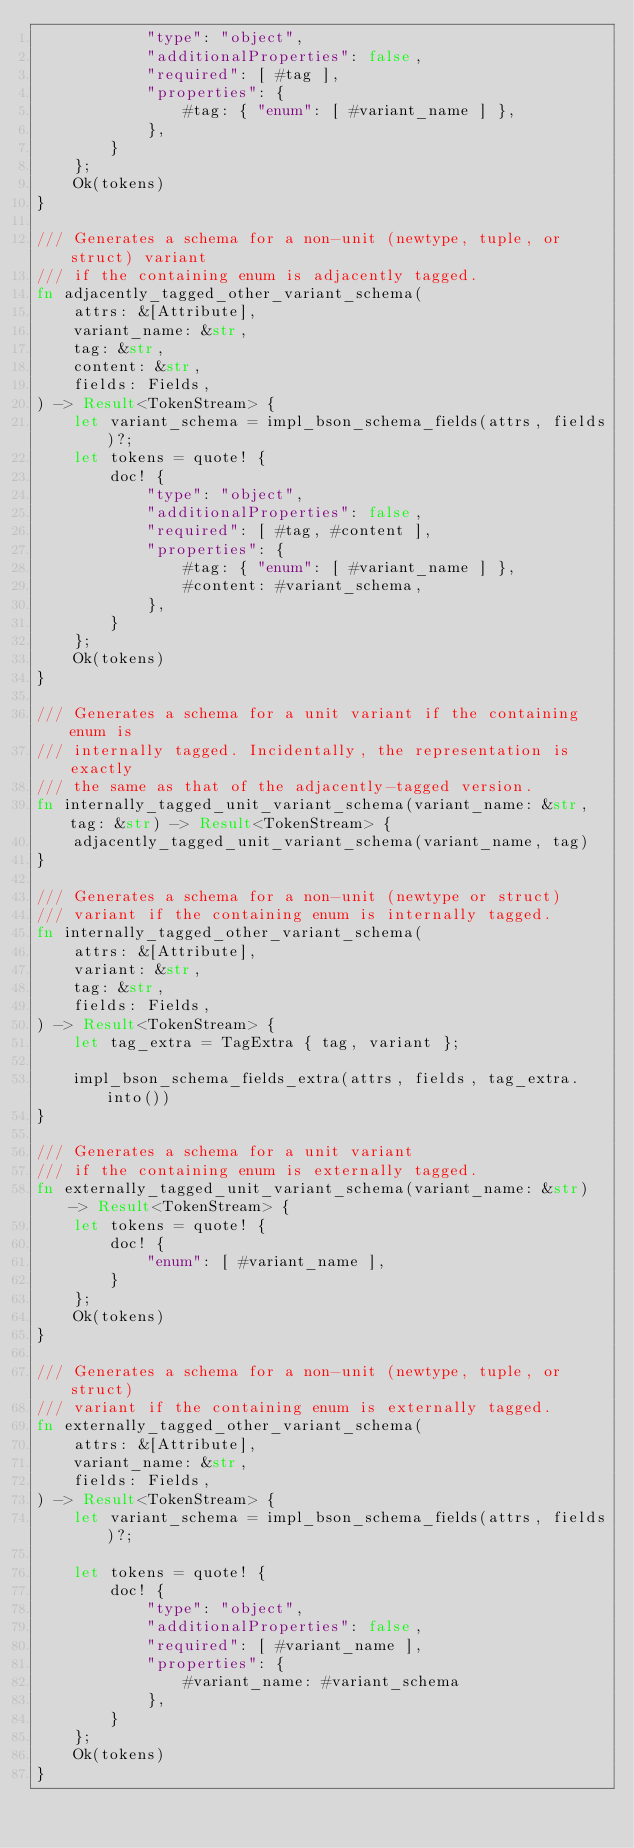<code> <loc_0><loc_0><loc_500><loc_500><_Rust_>            "type": "object",
            "additionalProperties": false,
            "required": [ #tag ],
            "properties": {
                #tag: { "enum": [ #variant_name ] },
            },
        }
    };
    Ok(tokens)
}

/// Generates a schema for a non-unit (newtype, tuple, or struct) variant
/// if the containing enum is adjacently tagged.
fn adjacently_tagged_other_variant_schema(
    attrs: &[Attribute],
    variant_name: &str,
    tag: &str,
    content: &str,
    fields: Fields,
) -> Result<TokenStream> {
    let variant_schema = impl_bson_schema_fields(attrs, fields)?;
    let tokens = quote! {
        doc! {
            "type": "object",
            "additionalProperties": false,
            "required": [ #tag, #content ],
            "properties": {
                #tag: { "enum": [ #variant_name ] },
                #content: #variant_schema,
            },
        }
    };
    Ok(tokens)
}

/// Generates a schema for a unit variant if the containing enum is
/// internally tagged. Incidentally, the representation is exactly
/// the same as that of the adjacently-tagged version.
fn internally_tagged_unit_variant_schema(variant_name: &str, tag: &str) -> Result<TokenStream> {
    adjacently_tagged_unit_variant_schema(variant_name, tag)
}

/// Generates a schema for a non-unit (newtype or struct)
/// variant if the containing enum is internally tagged.
fn internally_tagged_other_variant_schema(
    attrs: &[Attribute],
    variant: &str,
    tag: &str,
    fields: Fields,
) -> Result<TokenStream> {
    let tag_extra = TagExtra { tag, variant };

    impl_bson_schema_fields_extra(attrs, fields, tag_extra.into())
}

/// Generates a schema for a unit variant
/// if the containing enum is externally tagged.
fn externally_tagged_unit_variant_schema(variant_name: &str) -> Result<TokenStream> {
    let tokens = quote! {
        doc! {
            "enum": [ #variant_name ],
        }
    };
    Ok(tokens)
}

/// Generates a schema for a non-unit (newtype, tuple, or struct)
/// variant if the containing enum is externally tagged.
fn externally_tagged_other_variant_schema(
    attrs: &[Attribute],
    variant_name: &str,
    fields: Fields,
) -> Result<TokenStream> {
    let variant_schema = impl_bson_schema_fields(attrs, fields)?;

    let tokens = quote! {
        doc! {
            "type": "object",
            "additionalProperties": false,
            "required": [ #variant_name ],
            "properties": {
                #variant_name: #variant_schema
            },
        }
    };
    Ok(tokens)
}
</code> 